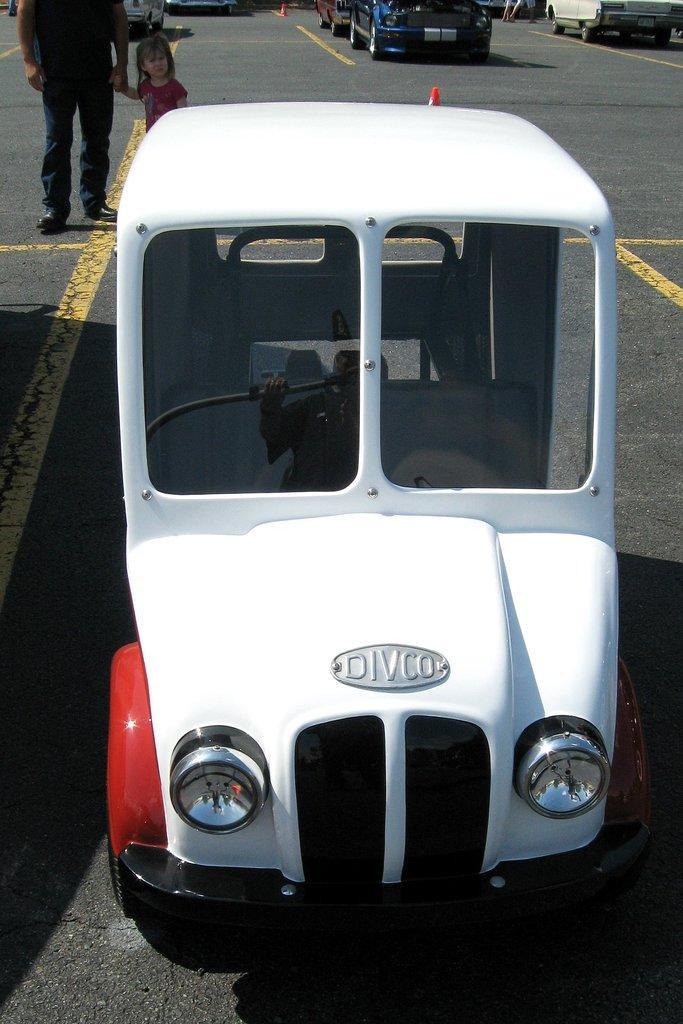In one or two sentences, can you explain what this image depicts? In this image there is a road at the bottom. There are people and vehicles on the left corner. There is a vehicle in the foreground. There are vehicles on the right corner. There is a road and there are vehicles in the background. 